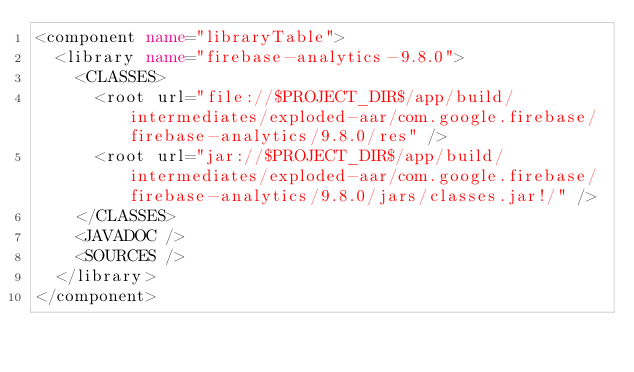<code> <loc_0><loc_0><loc_500><loc_500><_XML_><component name="libraryTable">
  <library name="firebase-analytics-9.8.0">
    <CLASSES>
      <root url="file://$PROJECT_DIR$/app/build/intermediates/exploded-aar/com.google.firebase/firebase-analytics/9.8.0/res" />
      <root url="jar://$PROJECT_DIR$/app/build/intermediates/exploded-aar/com.google.firebase/firebase-analytics/9.8.0/jars/classes.jar!/" />
    </CLASSES>
    <JAVADOC />
    <SOURCES />
  </library>
</component></code> 